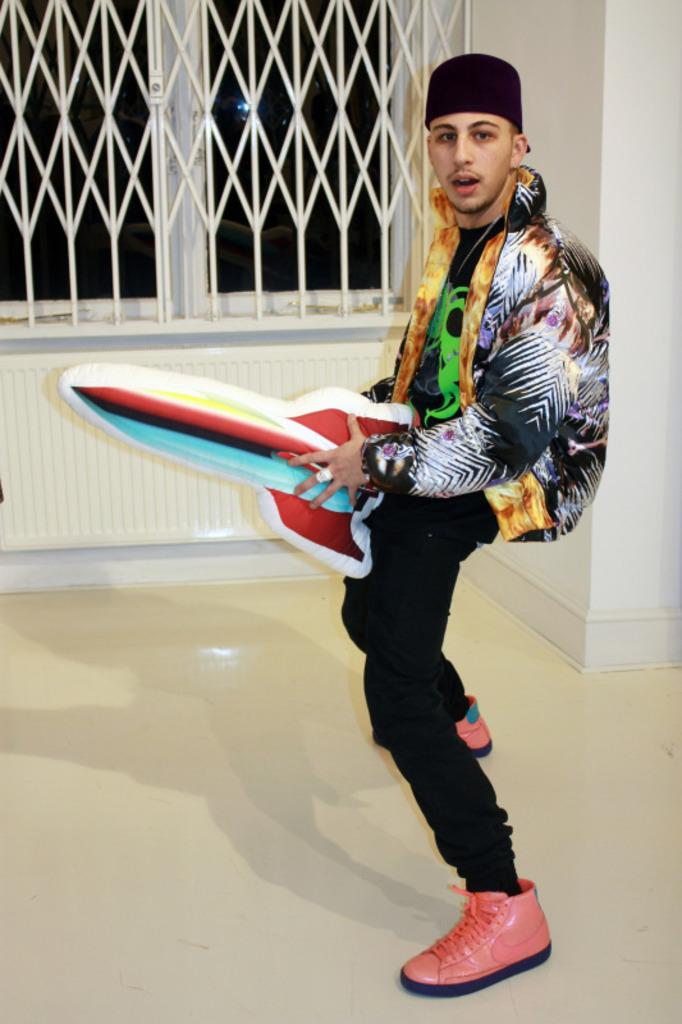What is the man in the image wearing on his head? The man is wearing a cap. What type of footwear is the man wearing in the image? The man is wearing shoes. What object is the man holding in the image? The man is holding a balloon rocket. What surface is the man standing on in the image? The man is standing on the floor. What can be seen in the background of the image? There are rods, a window, and walls in the background of the image. How many holes are visible in the image? There are no holes visible in the image. What type of competition is the man participating in, as seen in the image? There is no competition visible in the image. What type of seat is the man sitting on in the image? The man is not sitting in the image; he is standing on the floor. 